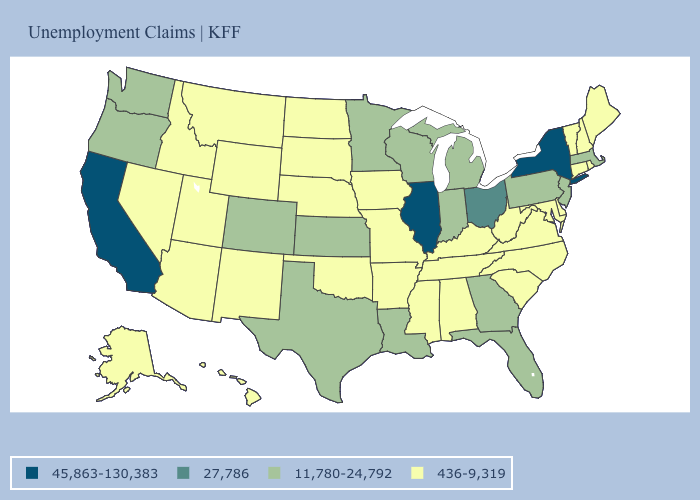Name the states that have a value in the range 27,786?
Be succinct. Ohio. Among the states that border North Carolina , which have the lowest value?
Give a very brief answer. South Carolina, Tennessee, Virginia. Name the states that have a value in the range 11,780-24,792?
Short answer required. Colorado, Florida, Georgia, Indiana, Kansas, Louisiana, Massachusetts, Michigan, Minnesota, New Jersey, Oregon, Pennsylvania, Texas, Washington, Wisconsin. What is the value of Wyoming?
Write a very short answer. 436-9,319. What is the value of Illinois?
Give a very brief answer. 45,863-130,383. What is the value of South Dakota?
Concise answer only. 436-9,319. Name the states that have a value in the range 11,780-24,792?
Keep it brief. Colorado, Florida, Georgia, Indiana, Kansas, Louisiana, Massachusetts, Michigan, Minnesota, New Jersey, Oregon, Pennsylvania, Texas, Washington, Wisconsin. What is the highest value in the Northeast ?
Keep it brief. 45,863-130,383. Does California have the highest value in the USA?
Give a very brief answer. Yes. How many symbols are there in the legend?
Quick response, please. 4. What is the lowest value in the USA?
Short answer required. 436-9,319. Name the states that have a value in the range 11,780-24,792?
Give a very brief answer. Colorado, Florida, Georgia, Indiana, Kansas, Louisiana, Massachusetts, Michigan, Minnesota, New Jersey, Oregon, Pennsylvania, Texas, Washington, Wisconsin. Does New York have the highest value in the USA?
Be succinct. Yes. Name the states that have a value in the range 11,780-24,792?
Write a very short answer. Colorado, Florida, Georgia, Indiana, Kansas, Louisiana, Massachusetts, Michigan, Minnesota, New Jersey, Oregon, Pennsylvania, Texas, Washington, Wisconsin. Name the states that have a value in the range 436-9,319?
Be succinct. Alabama, Alaska, Arizona, Arkansas, Connecticut, Delaware, Hawaii, Idaho, Iowa, Kentucky, Maine, Maryland, Mississippi, Missouri, Montana, Nebraska, Nevada, New Hampshire, New Mexico, North Carolina, North Dakota, Oklahoma, Rhode Island, South Carolina, South Dakota, Tennessee, Utah, Vermont, Virginia, West Virginia, Wyoming. 